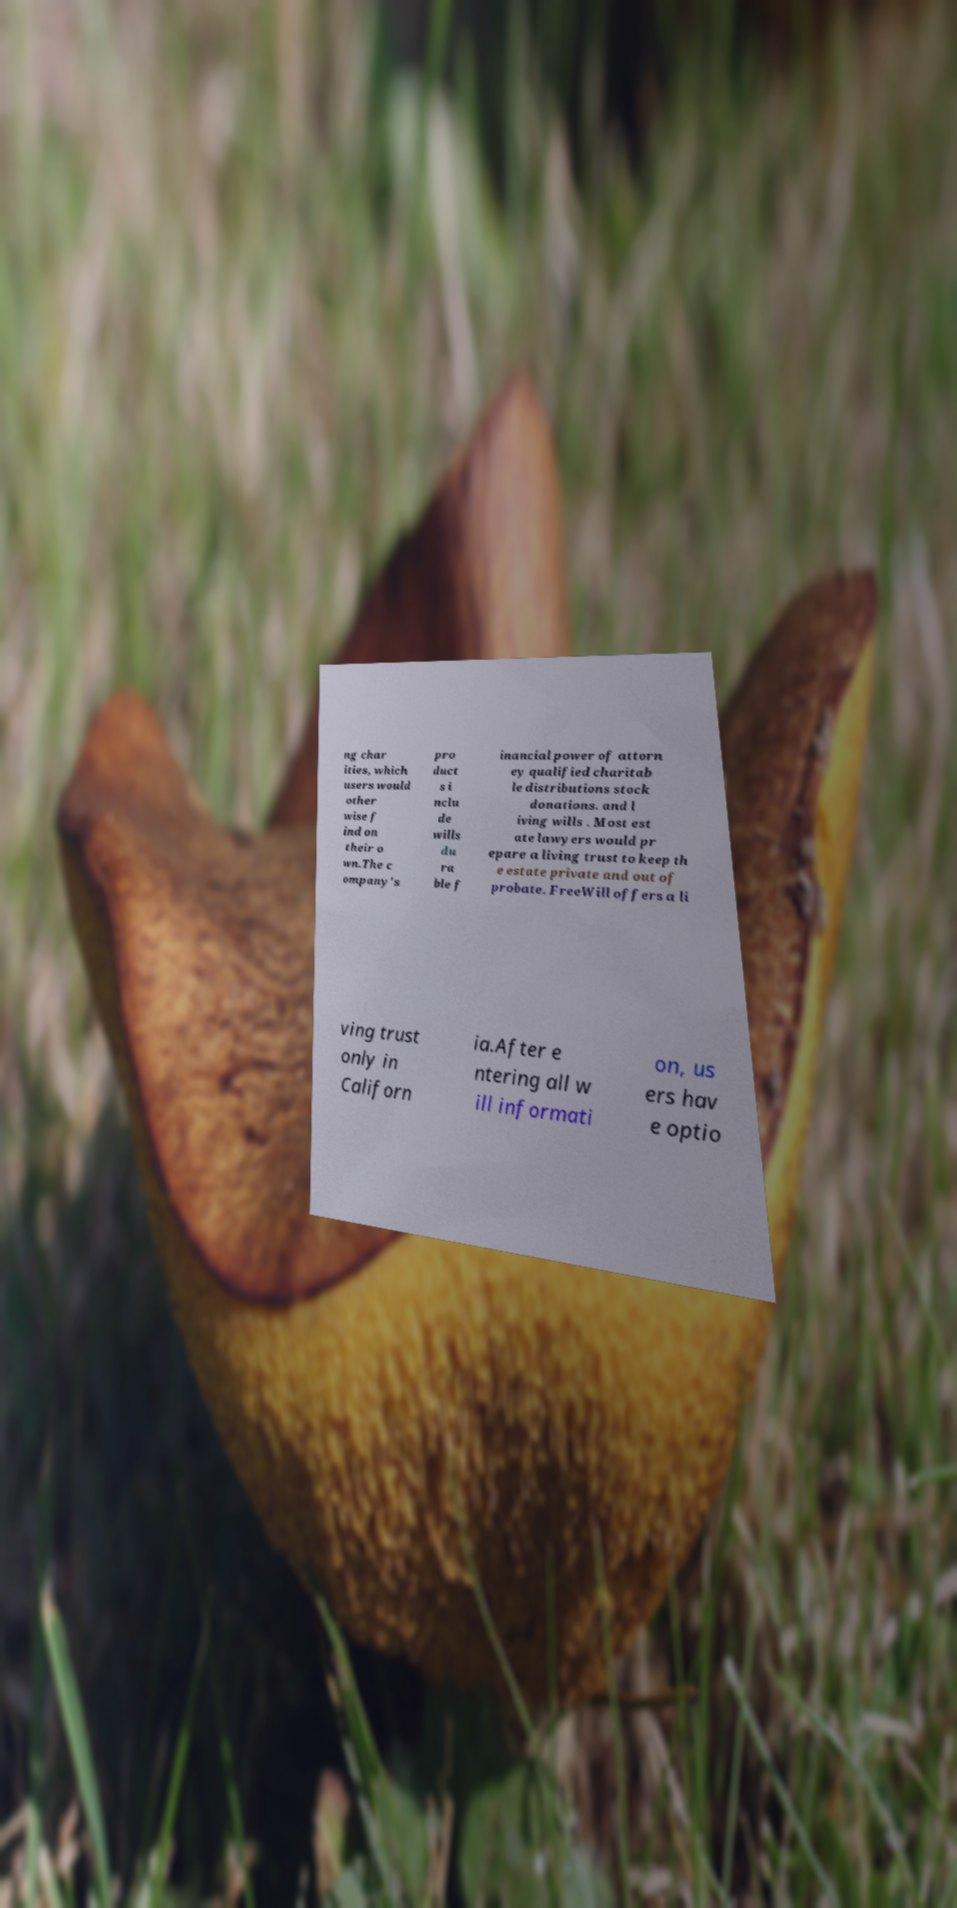Can you read and provide the text displayed in the image?This photo seems to have some interesting text. Can you extract and type it out for me? ng char ities, which users would other wise f ind on their o wn.The c ompany's pro duct s i nclu de wills du ra ble f inancial power of attorn ey qualified charitab le distributions stock donations. and l iving wills . Most est ate lawyers would pr epare a living trust to keep th e estate private and out of probate. FreeWill offers a li ving trust only in Californ ia.After e ntering all w ill informati on, us ers hav e optio 